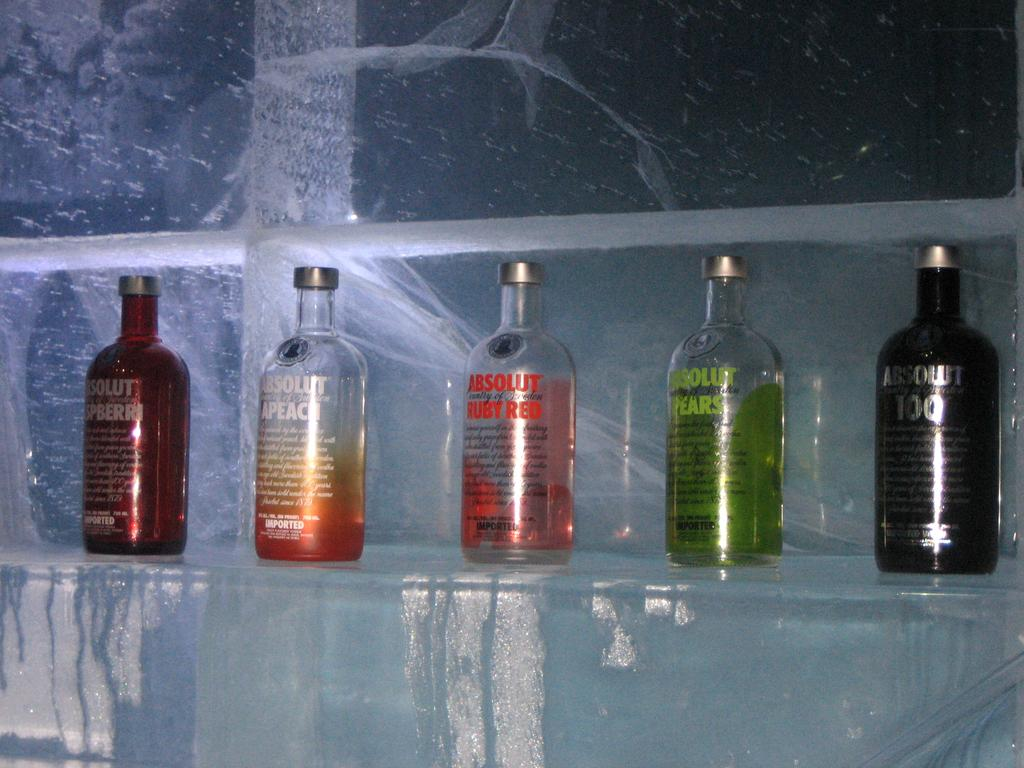How many bottles are visible in the image? There are five bottles in the image. What colors can be seen among the bottles? The bottles are in black, green, red, and orange colors. What route does the cannon take to reach the bottles in the image? There is no cannon present in the image, so it cannot be determined how it would reach the bottles. 